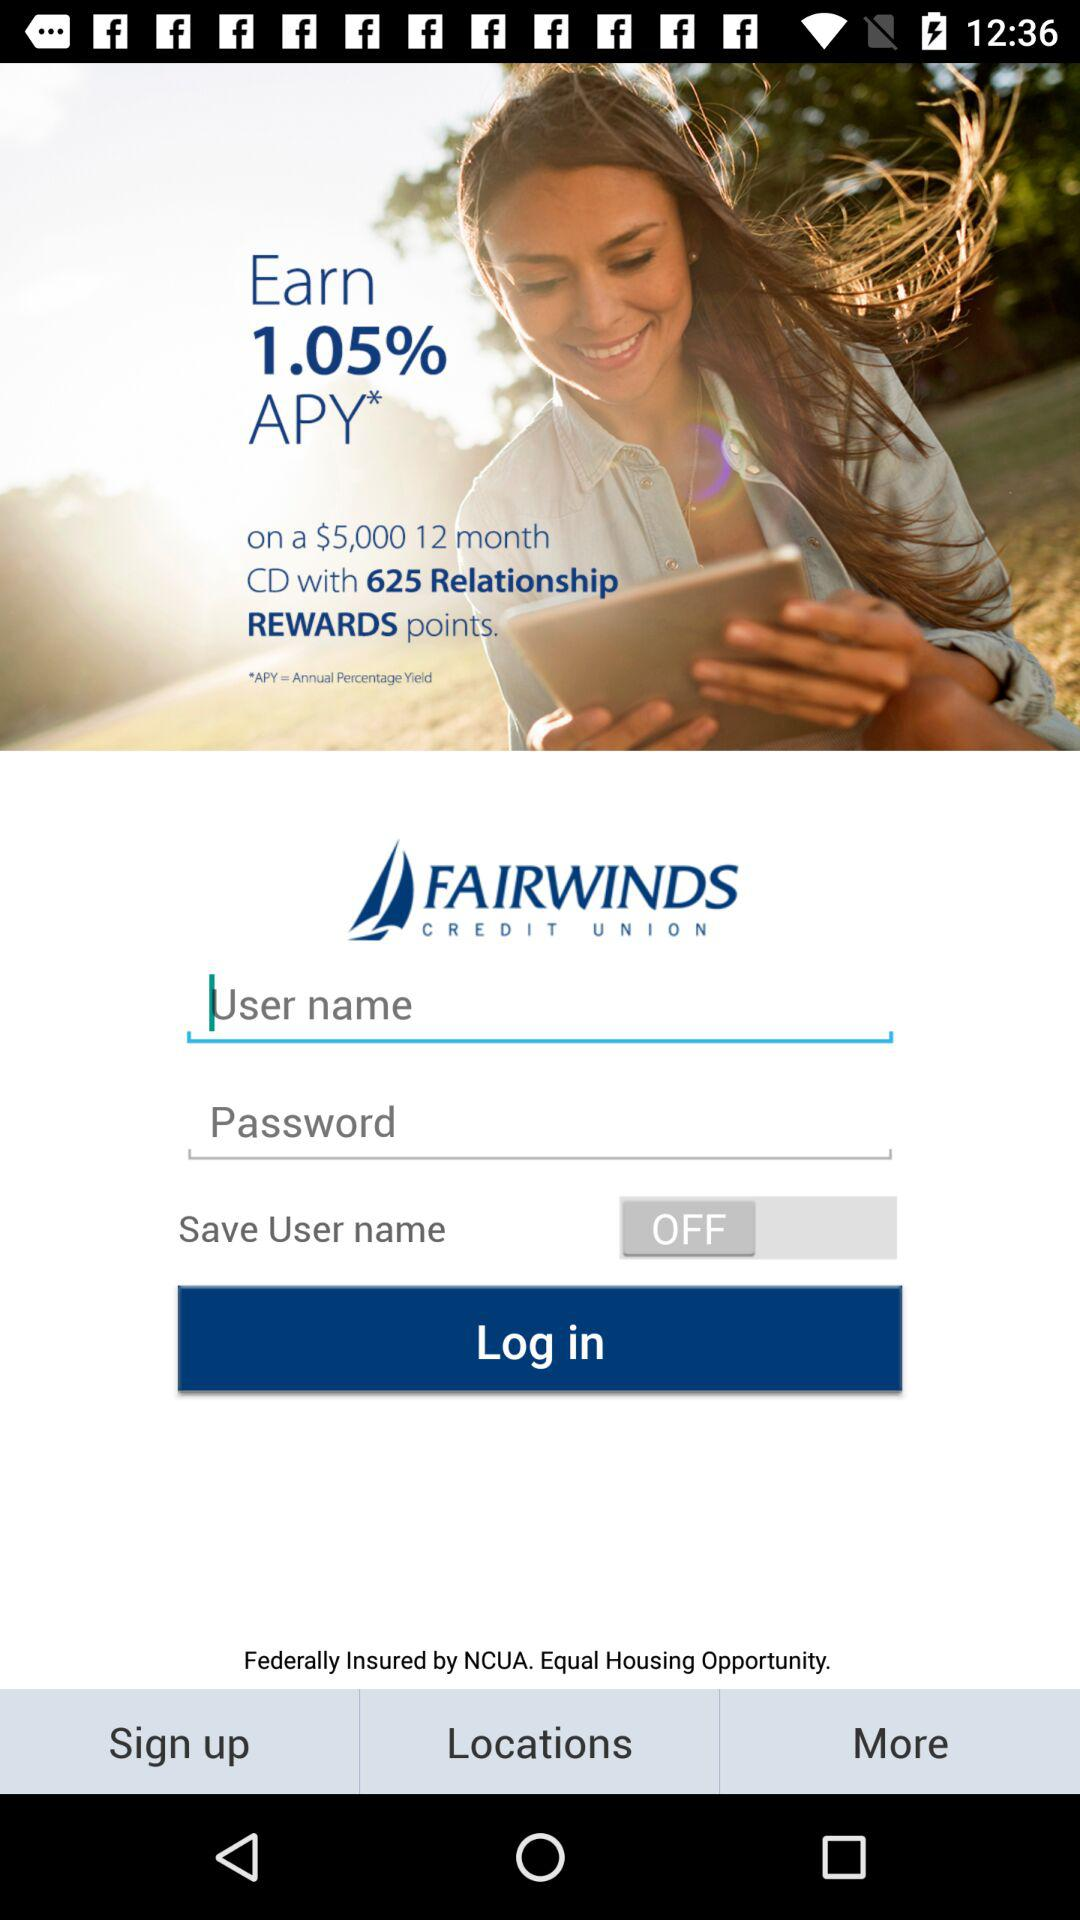What is the name of the application? The name of the application is "FAIRWINDS Mobile Banking". 